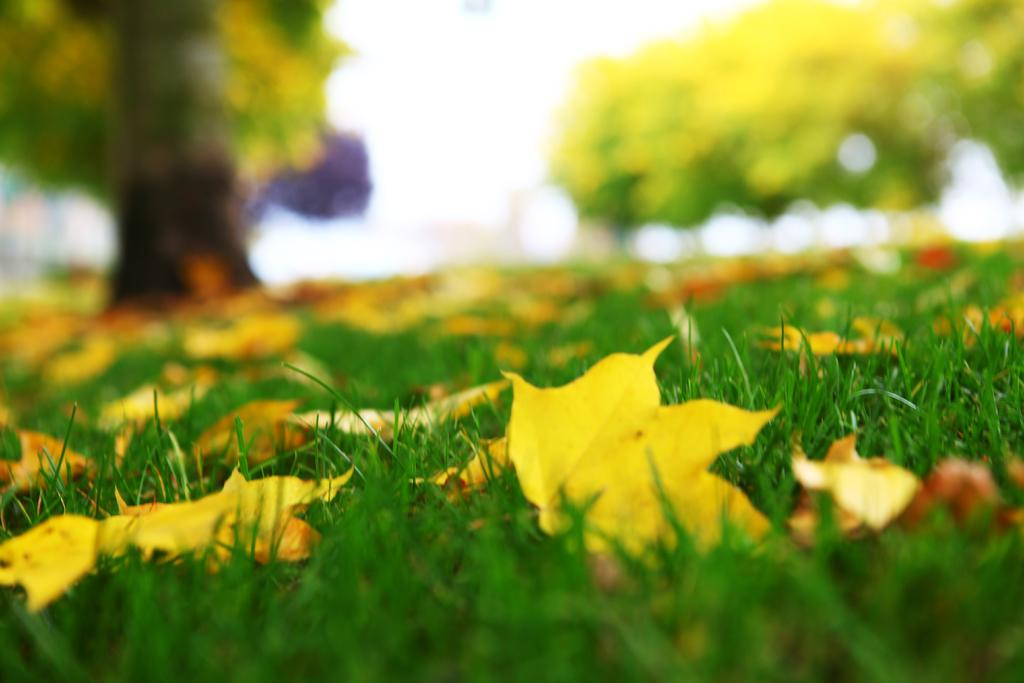What type of vegetation is present on the ground in the image? There is grass on the ground in the image. Are there any additional elements on the grass? Yes, there are leaves on the grass. Can you describe the background of the image? The background of the image is blurry. What type of paint is being used by the actor in the image? There is no actor or paint present in the image; it features grass and leaves on the ground with a blurry background. 